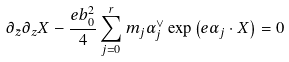Convert formula to latex. <formula><loc_0><loc_0><loc_500><loc_500>\partial _ { \bar { z } } \partial _ { z } X - \frac { e b _ { 0 } ^ { 2 } } { 4 } \sum _ { j = 0 } ^ { r } m _ { j } \alpha _ { j } ^ { \vee } \exp \left ( e \alpha _ { j } \cdot X \right ) = 0</formula> 